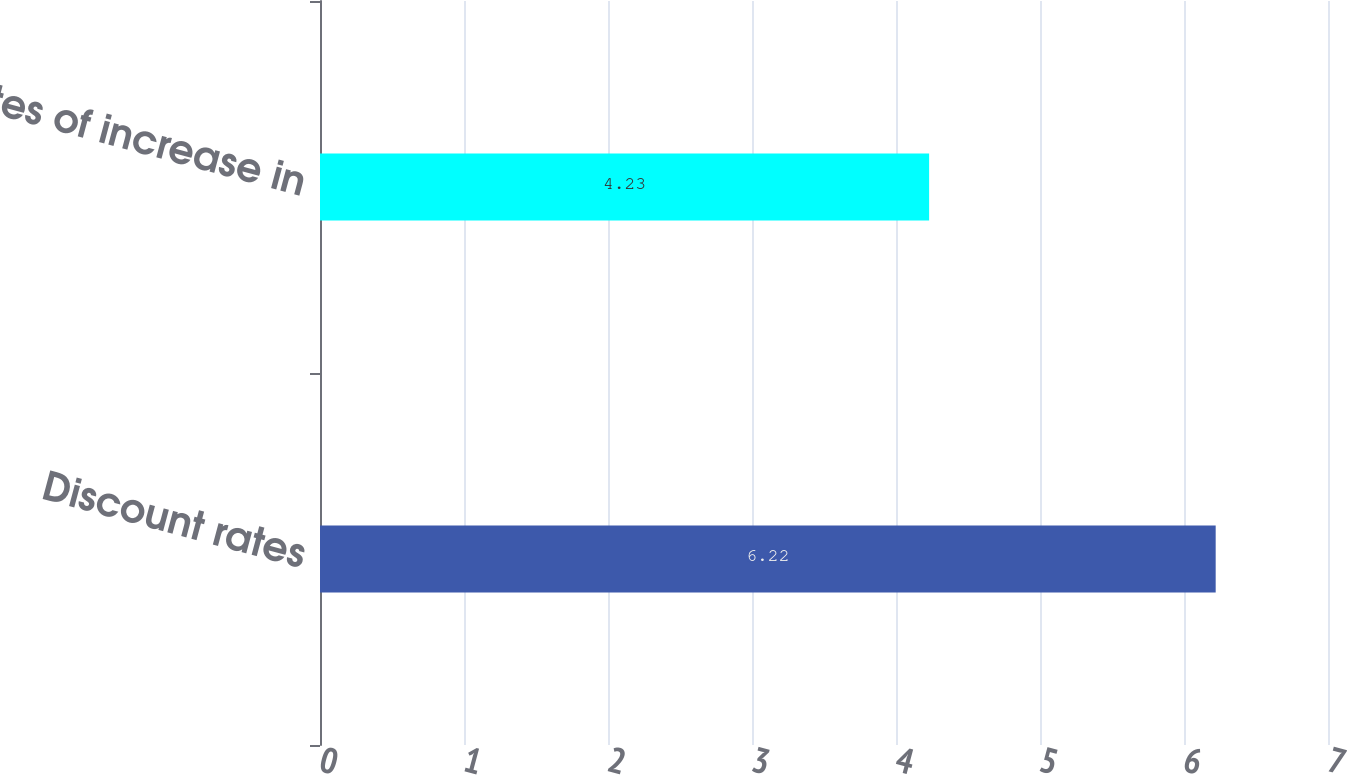Convert chart. <chart><loc_0><loc_0><loc_500><loc_500><bar_chart><fcel>Discount rates<fcel>Rates of increase in<nl><fcel>6.22<fcel>4.23<nl></chart> 